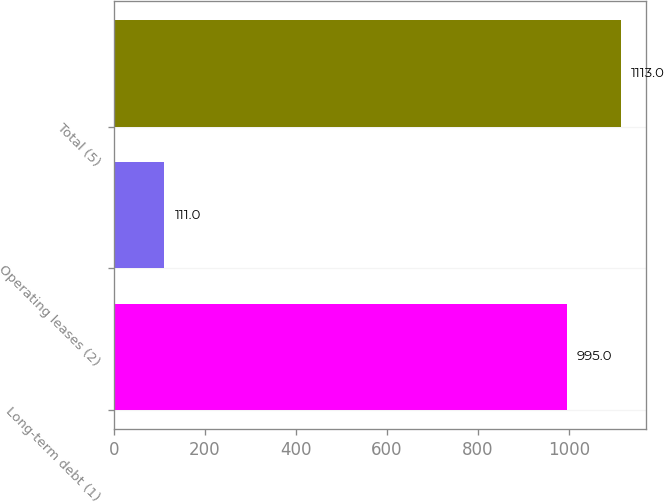Convert chart to OTSL. <chart><loc_0><loc_0><loc_500><loc_500><bar_chart><fcel>Long-term debt (1)<fcel>Operating leases (2)<fcel>Total (5)<nl><fcel>995<fcel>111<fcel>1113<nl></chart> 